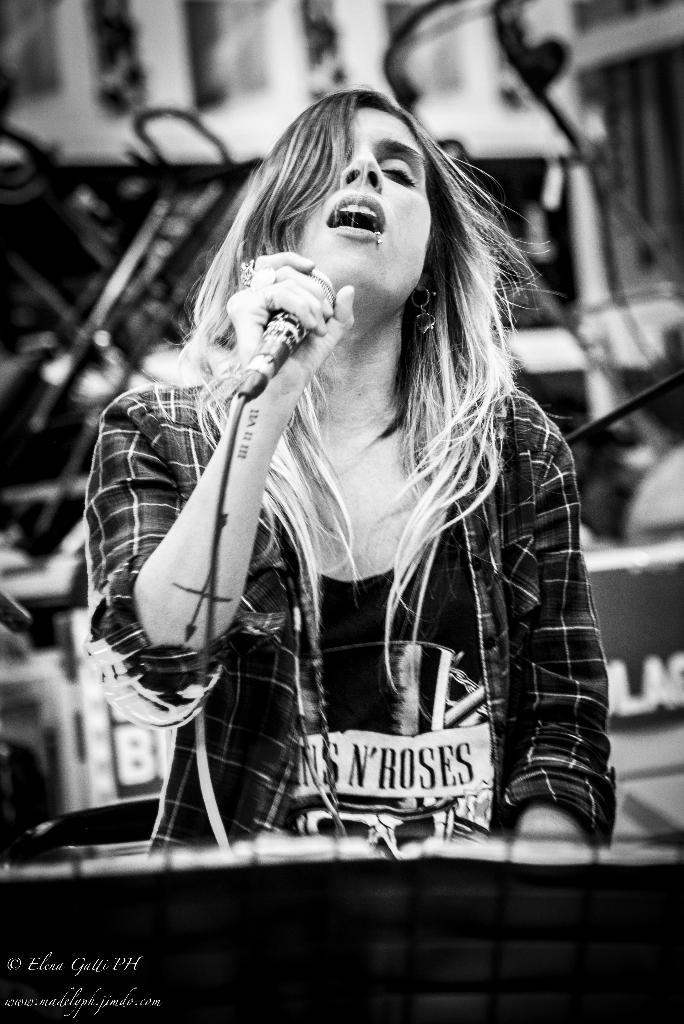Who is the main subject in the image? There is a woman in the image. What is the woman doing in the image? The woman is singing. What object is the woman holding in her hand? The woman is holding a microphone in her hand. What type of ice can be seen melting on the woman's hand in the image? There is no ice present in the image; the woman is holding a microphone. How does the woman show respect to the audience in the image? The image does not show any specific actions related to respect; it only shows the woman singing with a microphone. 